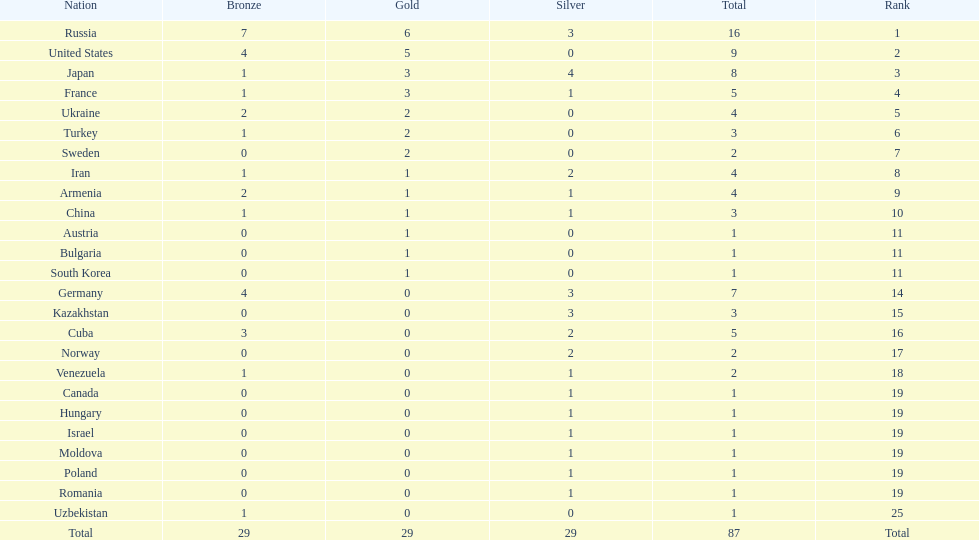Which countries competed in the 1995 world wrestling championships? Russia, United States, Japan, France, Ukraine, Turkey, Sweden, Iran, Armenia, China, Austria, Bulgaria, South Korea, Germany, Kazakhstan, Cuba, Norway, Venezuela, Canada, Hungary, Israel, Moldova, Poland, Romania, Uzbekistan. What country won only one medal? Austria, Bulgaria, South Korea, Canada, Hungary, Israel, Moldova, Poland, Romania, Uzbekistan. Which of these won a bronze medal? Uzbekistan. 